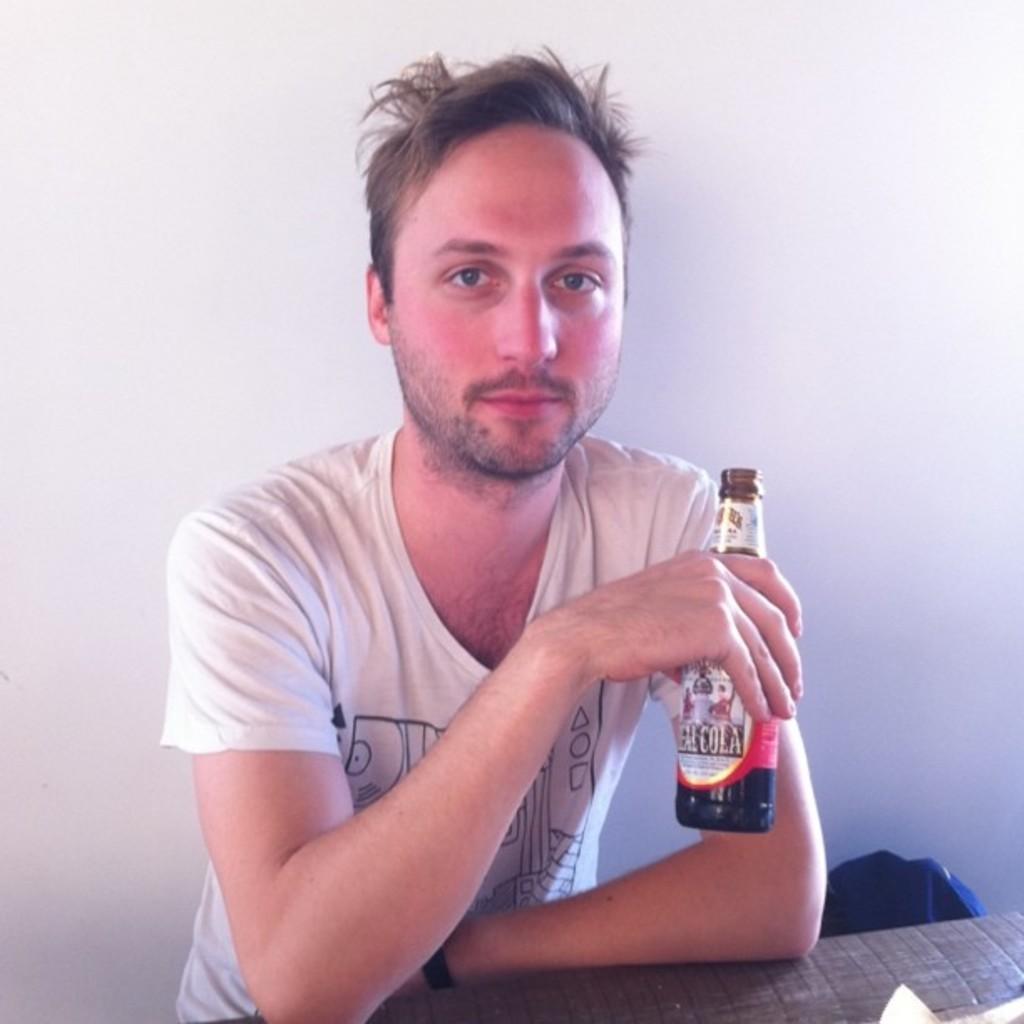Can you describe this image briefly? Here is a man sitting on a chair, he is wearing a white t-shirt and holding a wine bottle in his hand. and at the back there's a wall. 